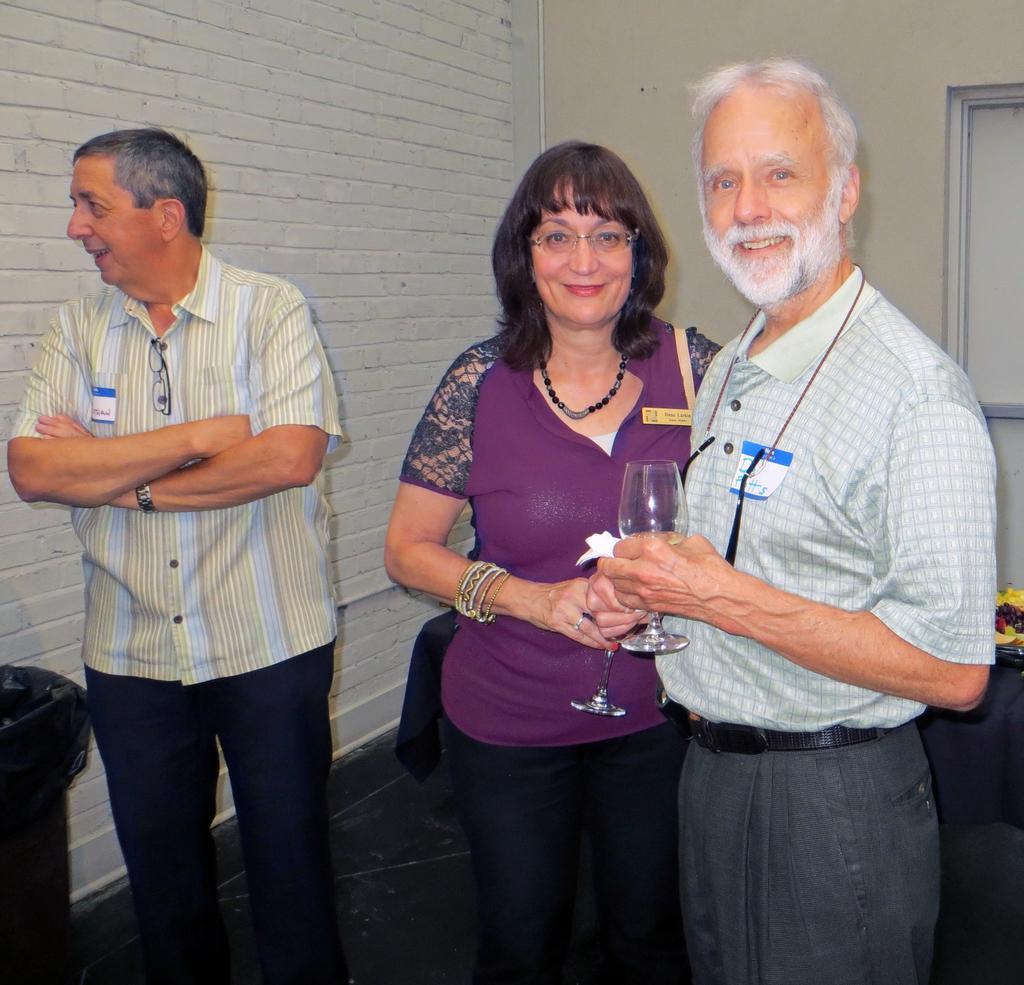In one or two sentences, can you explain what this image depicts? This picture shows few people standing. We see a man and a woman holding glasses in their hands and we see smile on their faces and women wore spectacles on her face and we see a dustbin on the side and we see a table on the back of them. 